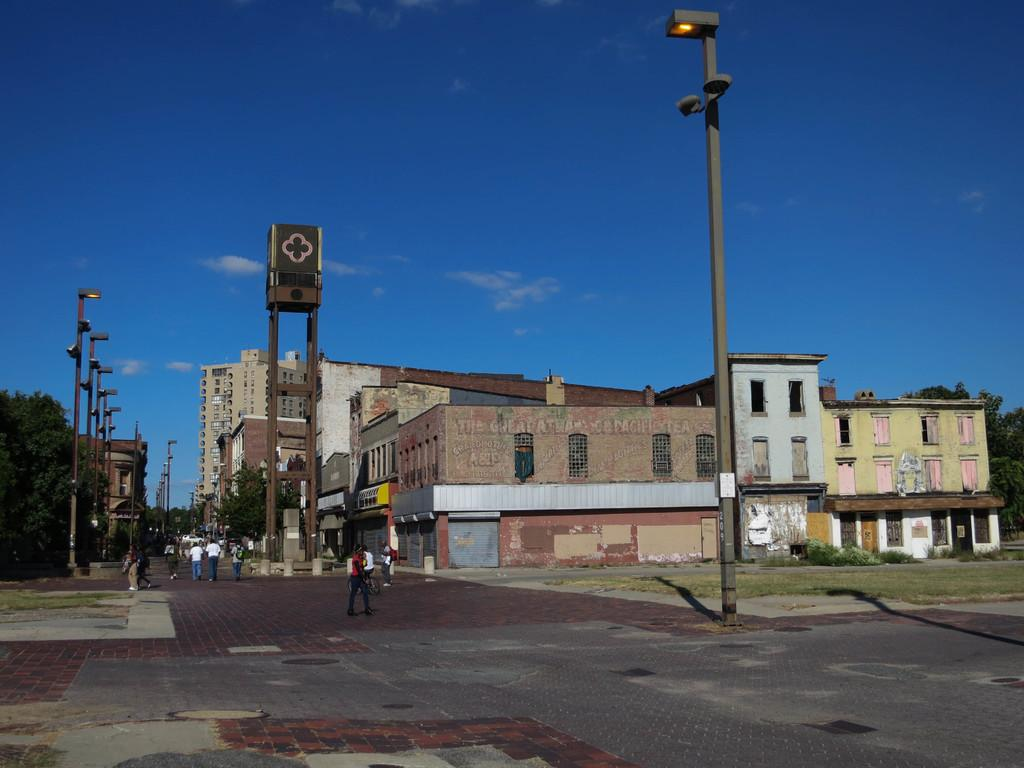What are the people in the image doing? The people in the image are walking at the bottom of the image. What can be seen on the left side of the image? There is a tree on the left side of the image. What is visible in the background of the image? There are buildings in the background of the image. What is located in the center of the image? There is a pole in the center of the image. What is visible at the top of the image? The sky is visible at the top of the image. Can you tell me how many girls are walking on the right side of the image? There is no mention of a girl in the image; the people walking are not specified as girls. What type of thrill can be experienced by the people walking in the image? The image does not provide any information about the emotions or experiences of the people walking, so it is not possible to determine if they are experiencing any thrill. 